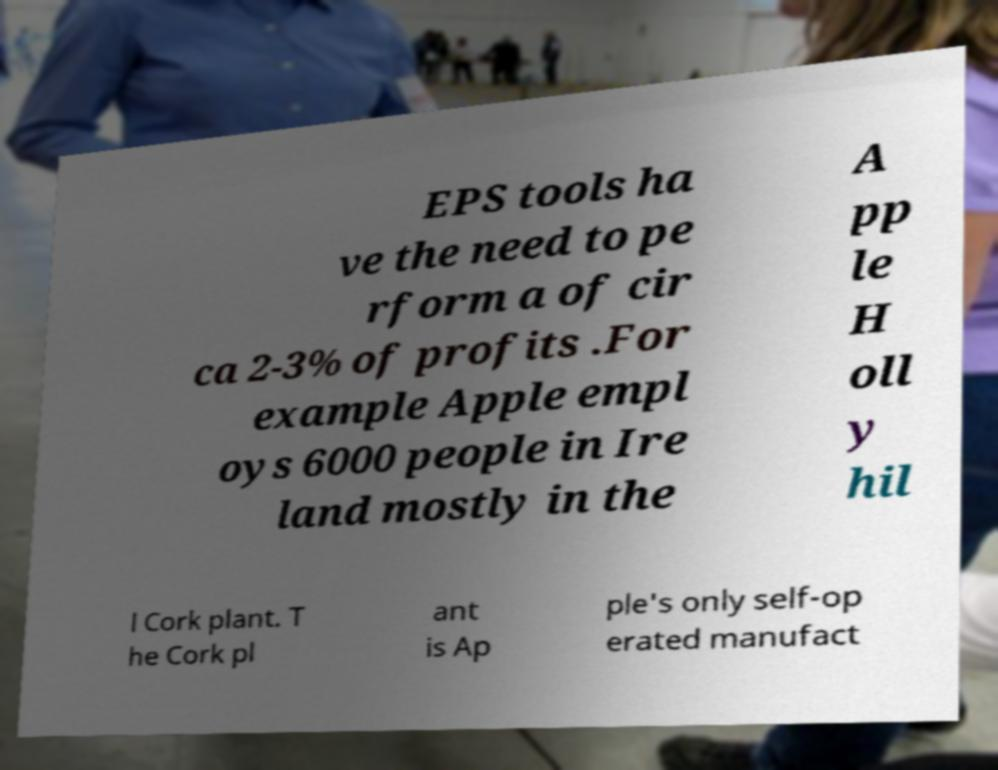Could you extract and type out the text from this image? EPS tools ha ve the need to pe rform a of cir ca 2-3% of profits .For example Apple empl oys 6000 people in Ire land mostly in the A pp le H oll y hil l Cork plant. T he Cork pl ant is Ap ple's only self-op erated manufact 